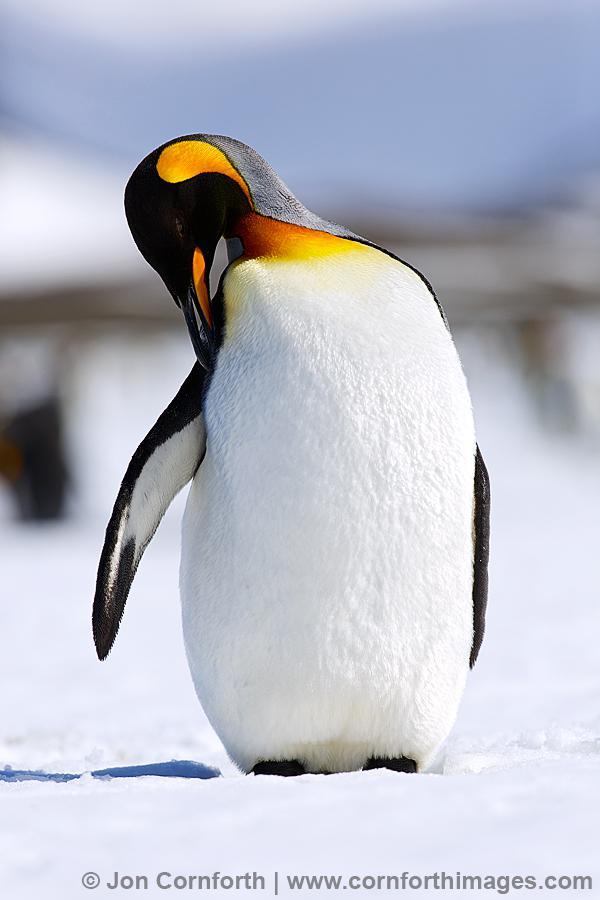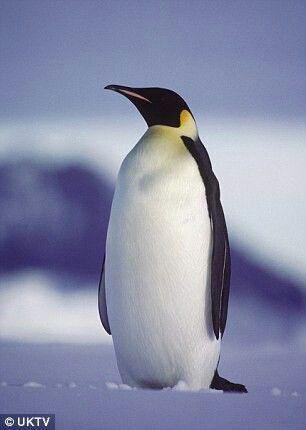The first image is the image on the left, the second image is the image on the right. For the images displayed, is the sentence "Each image shows an upright penguin that is standing in one place rather than walking." factually correct? Answer yes or no. Yes. The first image is the image on the left, the second image is the image on the right. For the images displayed, is the sentence "There is a penguin that is walking forward." factually correct? Answer yes or no. No. 